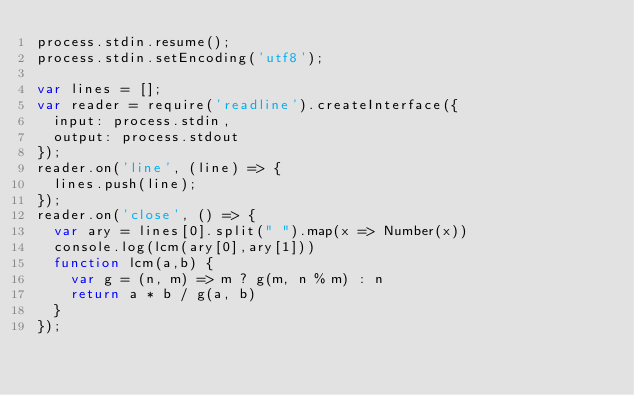<code> <loc_0><loc_0><loc_500><loc_500><_JavaScript_>process.stdin.resume();
process.stdin.setEncoding('utf8');

var lines = [];
var reader = require('readline').createInterface({
  input: process.stdin,
  output: process.stdout
});
reader.on('line', (line) => {
  lines.push(line);
});
reader.on('close', () => {
  var ary = lines[0].split(" ").map(x => Number(x))
  console.log(lcm(ary[0],ary[1]))
  function lcm(a,b) {
    var g = (n, m) => m ? g(m, n % m) : n
    return a * b / g(a, b)
  }
});</code> 